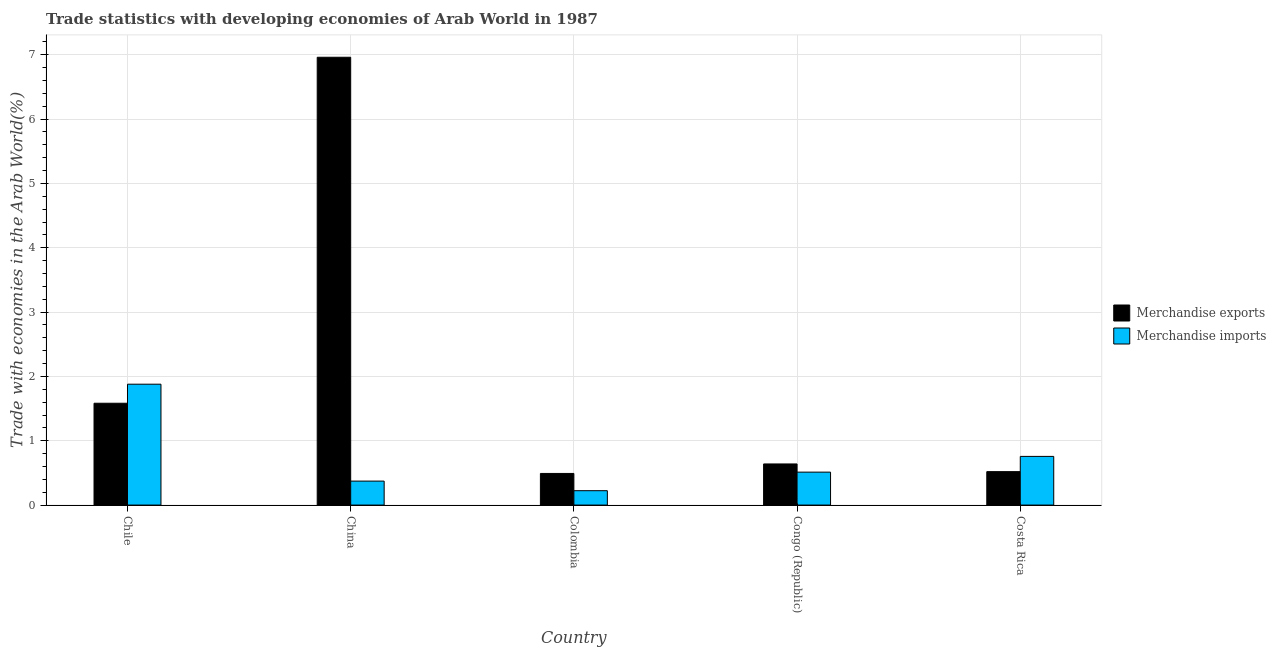How many groups of bars are there?
Offer a terse response. 5. Are the number of bars on each tick of the X-axis equal?
Offer a very short reply. Yes. How many bars are there on the 3rd tick from the right?
Offer a very short reply. 2. In how many cases, is the number of bars for a given country not equal to the number of legend labels?
Your answer should be very brief. 0. What is the merchandise imports in Colombia?
Your response must be concise. 0.22. Across all countries, what is the maximum merchandise imports?
Give a very brief answer. 1.88. Across all countries, what is the minimum merchandise exports?
Make the answer very short. 0.49. In which country was the merchandise imports minimum?
Your response must be concise. Colombia. What is the total merchandise imports in the graph?
Keep it short and to the point. 3.74. What is the difference between the merchandise exports in China and that in Congo (Republic)?
Your answer should be compact. 6.32. What is the difference between the merchandise exports in Congo (Republic) and the merchandise imports in China?
Give a very brief answer. 0.27. What is the average merchandise imports per country?
Make the answer very short. 0.75. What is the difference between the merchandise imports and merchandise exports in Congo (Republic)?
Offer a terse response. -0.13. In how many countries, is the merchandise imports greater than 7 %?
Offer a terse response. 0. What is the ratio of the merchandise imports in China to that in Colombia?
Offer a very short reply. 1.67. Is the difference between the merchandise exports in Chile and China greater than the difference between the merchandise imports in Chile and China?
Keep it short and to the point. No. What is the difference between the highest and the second highest merchandise exports?
Your answer should be compact. 5.38. What is the difference between the highest and the lowest merchandise imports?
Your response must be concise. 1.66. Is the sum of the merchandise exports in Chile and Colombia greater than the maximum merchandise imports across all countries?
Provide a succinct answer. Yes. What does the 2nd bar from the right in Colombia represents?
Keep it short and to the point. Merchandise exports. How many bars are there?
Provide a short and direct response. 10. What is the difference between two consecutive major ticks on the Y-axis?
Your response must be concise. 1. Does the graph contain grids?
Your answer should be compact. Yes. How many legend labels are there?
Provide a short and direct response. 2. How are the legend labels stacked?
Provide a short and direct response. Vertical. What is the title of the graph?
Make the answer very short. Trade statistics with developing economies of Arab World in 1987. What is the label or title of the X-axis?
Offer a very short reply. Country. What is the label or title of the Y-axis?
Provide a short and direct response. Trade with economies in the Arab World(%). What is the Trade with economies in the Arab World(%) in Merchandise exports in Chile?
Your answer should be very brief. 1.58. What is the Trade with economies in the Arab World(%) of Merchandise imports in Chile?
Provide a short and direct response. 1.88. What is the Trade with economies in the Arab World(%) in Merchandise exports in China?
Keep it short and to the point. 6.96. What is the Trade with economies in the Arab World(%) in Merchandise imports in China?
Keep it short and to the point. 0.37. What is the Trade with economies in the Arab World(%) of Merchandise exports in Colombia?
Make the answer very short. 0.49. What is the Trade with economies in the Arab World(%) in Merchandise imports in Colombia?
Make the answer very short. 0.22. What is the Trade with economies in the Arab World(%) of Merchandise exports in Congo (Republic)?
Ensure brevity in your answer.  0.64. What is the Trade with economies in the Arab World(%) in Merchandise imports in Congo (Republic)?
Ensure brevity in your answer.  0.51. What is the Trade with economies in the Arab World(%) of Merchandise exports in Costa Rica?
Ensure brevity in your answer.  0.52. What is the Trade with economies in the Arab World(%) of Merchandise imports in Costa Rica?
Give a very brief answer. 0.76. Across all countries, what is the maximum Trade with economies in the Arab World(%) in Merchandise exports?
Keep it short and to the point. 6.96. Across all countries, what is the maximum Trade with economies in the Arab World(%) in Merchandise imports?
Provide a succinct answer. 1.88. Across all countries, what is the minimum Trade with economies in the Arab World(%) in Merchandise exports?
Provide a succinct answer. 0.49. Across all countries, what is the minimum Trade with economies in the Arab World(%) in Merchandise imports?
Give a very brief answer. 0.22. What is the total Trade with economies in the Arab World(%) in Merchandise exports in the graph?
Offer a very short reply. 10.19. What is the total Trade with economies in the Arab World(%) in Merchandise imports in the graph?
Offer a very short reply. 3.74. What is the difference between the Trade with economies in the Arab World(%) of Merchandise exports in Chile and that in China?
Your response must be concise. -5.38. What is the difference between the Trade with economies in the Arab World(%) in Merchandise imports in Chile and that in China?
Ensure brevity in your answer.  1.51. What is the difference between the Trade with economies in the Arab World(%) in Merchandise exports in Chile and that in Colombia?
Make the answer very short. 1.09. What is the difference between the Trade with economies in the Arab World(%) of Merchandise imports in Chile and that in Colombia?
Offer a terse response. 1.66. What is the difference between the Trade with economies in the Arab World(%) of Merchandise exports in Chile and that in Congo (Republic)?
Ensure brevity in your answer.  0.94. What is the difference between the Trade with economies in the Arab World(%) of Merchandise imports in Chile and that in Congo (Republic)?
Provide a succinct answer. 1.37. What is the difference between the Trade with economies in the Arab World(%) in Merchandise exports in Chile and that in Costa Rica?
Your response must be concise. 1.06. What is the difference between the Trade with economies in the Arab World(%) in Merchandise imports in Chile and that in Costa Rica?
Your answer should be compact. 1.12. What is the difference between the Trade with economies in the Arab World(%) of Merchandise exports in China and that in Colombia?
Your answer should be very brief. 6.47. What is the difference between the Trade with economies in the Arab World(%) in Merchandise imports in China and that in Colombia?
Your answer should be compact. 0.15. What is the difference between the Trade with economies in the Arab World(%) of Merchandise exports in China and that in Congo (Republic)?
Provide a succinct answer. 6.32. What is the difference between the Trade with economies in the Arab World(%) of Merchandise imports in China and that in Congo (Republic)?
Offer a very short reply. -0.14. What is the difference between the Trade with economies in the Arab World(%) of Merchandise exports in China and that in Costa Rica?
Ensure brevity in your answer.  6.44. What is the difference between the Trade with economies in the Arab World(%) in Merchandise imports in China and that in Costa Rica?
Provide a short and direct response. -0.38. What is the difference between the Trade with economies in the Arab World(%) in Merchandise exports in Colombia and that in Congo (Republic)?
Your answer should be compact. -0.15. What is the difference between the Trade with economies in the Arab World(%) in Merchandise imports in Colombia and that in Congo (Republic)?
Give a very brief answer. -0.29. What is the difference between the Trade with economies in the Arab World(%) in Merchandise exports in Colombia and that in Costa Rica?
Ensure brevity in your answer.  -0.03. What is the difference between the Trade with economies in the Arab World(%) of Merchandise imports in Colombia and that in Costa Rica?
Provide a short and direct response. -0.53. What is the difference between the Trade with economies in the Arab World(%) in Merchandise exports in Congo (Republic) and that in Costa Rica?
Your answer should be very brief. 0.12. What is the difference between the Trade with economies in the Arab World(%) in Merchandise imports in Congo (Republic) and that in Costa Rica?
Offer a terse response. -0.24. What is the difference between the Trade with economies in the Arab World(%) of Merchandise exports in Chile and the Trade with economies in the Arab World(%) of Merchandise imports in China?
Your answer should be very brief. 1.21. What is the difference between the Trade with economies in the Arab World(%) of Merchandise exports in Chile and the Trade with economies in the Arab World(%) of Merchandise imports in Colombia?
Provide a short and direct response. 1.36. What is the difference between the Trade with economies in the Arab World(%) in Merchandise exports in Chile and the Trade with economies in the Arab World(%) in Merchandise imports in Congo (Republic)?
Provide a succinct answer. 1.07. What is the difference between the Trade with economies in the Arab World(%) of Merchandise exports in Chile and the Trade with economies in the Arab World(%) of Merchandise imports in Costa Rica?
Your answer should be compact. 0.83. What is the difference between the Trade with economies in the Arab World(%) in Merchandise exports in China and the Trade with economies in the Arab World(%) in Merchandise imports in Colombia?
Keep it short and to the point. 6.74. What is the difference between the Trade with economies in the Arab World(%) in Merchandise exports in China and the Trade with economies in the Arab World(%) in Merchandise imports in Congo (Republic)?
Make the answer very short. 6.45. What is the difference between the Trade with economies in the Arab World(%) in Merchandise exports in China and the Trade with economies in the Arab World(%) in Merchandise imports in Costa Rica?
Your response must be concise. 6.2. What is the difference between the Trade with economies in the Arab World(%) in Merchandise exports in Colombia and the Trade with economies in the Arab World(%) in Merchandise imports in Congo (Republic)?
Your response must be concise. -0.02. What is the difference between the Trade with economies in the Arab World(%) in Merchandise exports in Colombia and the Trade with economies in the Arab World(%) in Merchandise imports in Costa Rica?
Your answer should be compact. -0.27. What is the difference between the Trade with economies in the Arab World(%) in Merchandise exports in Congo (Republic) and the Trade with economies in the Arab World(%) in Merchandise imports in Costa Rica?
Ensure brevity in your answer.  -0.12. What is the average Trade with economies in the Arab World(%) in Merchandise exports per country?
Keep it short and to the point. 2.04. What is the average Trade with economies in the Arab World(%) of Merchandise imports per country?
Offer a terse response. 0.75. What is the difference between the Trade with economies in the Arab World(%) in Merchandise exports and Trade with economies in the Arab World(%) in Merchandise imports in Chile?
Provide a short and direct response. -0.3. What is the difference between the Trade with economies in the Arab World(%) of Merchandise exports and Trade with economies in the Arab World(%) of Merchandise imports in China?
Keep it short and to the point. 6.59. What is the difference between the Trade with economies in the Arab World(%) of Merchandise exports and Trade with economies in the Arab World(%) of Merchandise imports in Colombia?
Offer a very short reply. 0.27. What is the difference between the Trade with economies in the Arab World(%) in Merchandise exports and Trade with economies in the Arab World(%) in Merchandise imports in Congo (Republic)?
Your response must be concise. 0.13. What is the difference between the Trade with economies in the Arab World(%) of Merchandise exports and Trade with economies in the Arab World(%) of Merchandise imports in Costa Rica?
Provide a succinct answer. -0.24. What is the ratio of the Trade with economies in the Arab World(%) of Merchandise exports in Chile to that in China?
Make the answer very short. 0.23. What is the ratio of the Trade with economies in the Arab World(%) in Merchandise imports in Chile to that in China?
Your answer should be very brief. 5.04. What is the ratio of the Trade with economies in the Arab World(%) of Merchandise exports in Chile to that in Colombia?
Your answer should be very brief. 3.22. What is the ratio of the Trade with economies in the Arab World(%) of Merchandise imports in Chile to that in Colombia?
Provide a succinct answer. 8.41. What is the ratio of the Trade with economies in the Arab World(%) in Merchandise exports in Chile to that in Congo (Republic)?
Keep it short and to the point. 2.48. What is the ratio of the Trade with economies in the Arab World(%) in Merchandise imports in Chile to that in Congo (Republic)?
Offer a terse response. 3.67. What is the ratio of the Trade with economies in the Arab World(%) in Merchandise exports in Chile to that in Costa Rica?
Give a very brief answer. 3.05. What is the ratio of the Trade with economies in the Arab World(%) of Merchandise imports in Chile to that in Costa Rica?
Offer a terse response. 2.48. What is the ratio of the Trade with economies in the Arab World(%) of Merchandise exports in China to that in Colombia?
Your response must be concise. 14.16. What is the ratio of the Trade with economies in the Arab World(%) of Merchandise imports in China to that in Colombia?
Make the answer very short. 1.67. What is the ratio of the Trade with economies in the Arab World(%) in Merchandise exports in China to that in Congo (Republic)?
Provide a short and direct response. 10.89. What is the ratio of the Trade with economies in the Arab World(%) in Merchandise imports in China to that in Congo (Republic)?
Provide a short and direct response. 0.73. What is the ratio of the Trade with economies in the Arab World(%) of Merchandise exports in China to that in Costa Rica?
Make the answer very short. 13.39. What is the ratio of the Trade with economies in the Arab World(%) in Merchandise imports in China to that in Costa Rica?
Your response must be concise. 0.49. What is the ratio of the Trade with economies in the Arab World(%) of Merchandise exports in Colombia to that in Congo (Republic)?
Give a very brief answer. 0.77. What is the ratio of the Trade with economies in the Arab World(%) in Merchandise imports in Colombia to that in Congo (Republic)?
Make the answer very short. 0.44. What is the ratio of the Trade with economies in the Arab World(%) of Merchandise exports in Colombia to that in Costa Rica?
Keep it short and to the point. 0.95. What is the ratio of the Trade with economies in the Arab World(%) in Merchandise imports in Colombia to that in Costa Rica?
Ensure brevity in your answer.  0.3. What is the ratio of the Trade with economies in the Arab World(%) in Merchandise exports in Congo (Republic) to that in Costa Rica?
Provide a short and direct response. 1.23. What is the ratio of the Trade with economies in the Arab World(%) in Merchandise imports in Congo (Republic) to that in Costa Rica?
Your answer should be compact. 0.68. What is the difference between the highest and the second highest Trade with economies in the Arab World(%) of Merchandise exports?
Keep it short and to the point. 5.38. What is the difference between the highest and the second highest Trade with economies in the Arab World(%) in Merchandise imports?
Provide a succinct answer. 1.12. What is the difference between the highest and the lowest Trade with economies in the Arab World(%) in Merchandise exports?
Give a very brief answer. 6.47. What is the difference between the highest and the lowest Trade with economies in the Arab World(%) in Merchandise imports?
Ensure brevity in your answer.  1.66. 